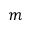<formula> <loc_0><loc_0><loc_500><loc_500>m</formula> 